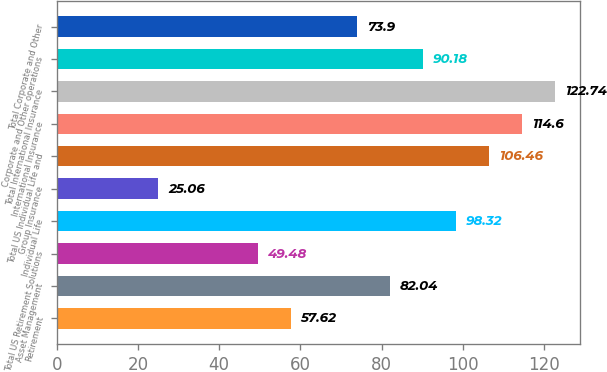<chart> <loc_0><loc_0><loc_500><loc_500><bar_chart><fcel>Retirement<fcel>Asset Management<fcel>Total US Retirement Solutions<fcel>Individual Life<fcel>Group Insurance<fcel>Total US Individual Life and<fcel>International Insurance<fcel>Total International Insurance<fcel>Corporate and Other operations<fcel>Total Corporate and Other<nl><fcel>57.62<fcel>82.04<fcel>49.48<fcel>98.32<fcel>25.06<fcel>106.46<fcel>114.6<fcel>122.74<fcel>90.18<fcel>73.9<nl></chart> 